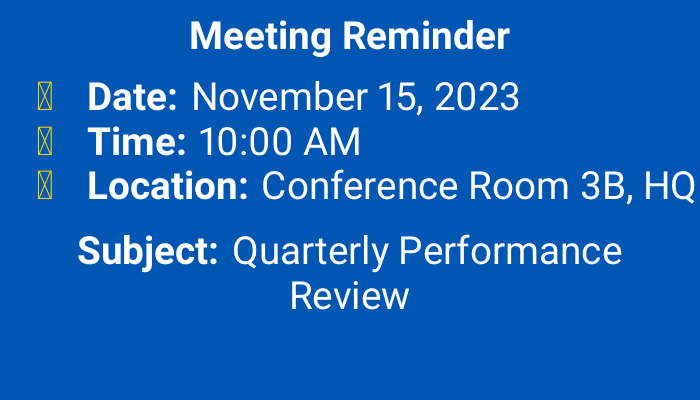What is the date of the meeting? The date of the meeting is presented prominently in the document, specifically noted as November 15, 2023.
Answer: November 15, 2023 What time does the meeting start? The time the meeting is set to begin is indicated clearly in the document as 10:00 AM.
Answer: 10:00 AM Where is the meeting located? The location of the meeting is explicitly mentioned in the document as Conference Room 3B, HQ.
Answer: Conference Room 3B, HQ What is the subject of the meeting? The subject of the meeting is highlighted in the document, specified as Quarterly Performance Review.
Answer: Quarterly Performance Review Who are the key participants? The document lists several key participants, indicating their names and job titles.
Answer: Jane Smith, Michael Johnson, Emily Davis, David Wilson How many key participants are listed? Counting the names in the key participants section of the document will reveal the total number of individuals mentioned.
Answer: 4 What role does Jane Smith have? The document specifies Jane Smith’s position as CEO within the key participants section.
Answer: CEO Is this meeting a quarterly review? The subject line mentions the meeting type, indicating that it is a quarterly review, specifically labeled as Quarterly Performance Review.
Answer: Yes What color is used for the document background? The background color of the document is specified in the code and is referred to as primary color, which is blue.
Answer: Blue 